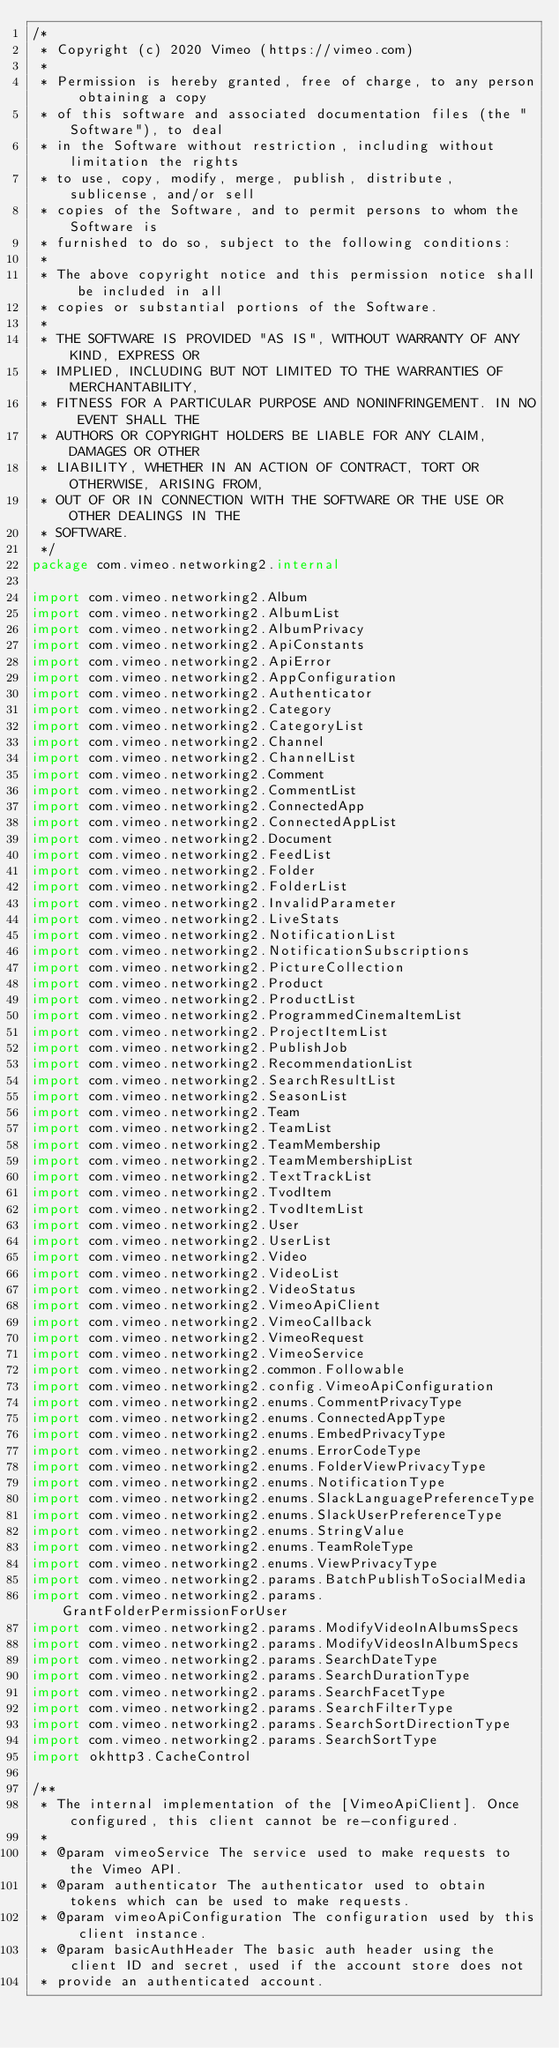<code> <loc_0><loc_0><loc_500><loc_500><_Kotlin_>/*
 * Copyright (c) 2020 Vimeo (https://vimeo.com)
 *
 * Permission is hereby granted, free of charge, to any person obtaining a copy
 * of this software and associated documentation files (the "Software"), to deal
 * in the Software without restriction, including without limitation the rights
 * to use, copy, modify, merge, publish, distribute, sublicense, and/or sell
 * copies of the Software, and to permit persons to whom the Software is
 * furnished to do so, subject to the following conditions:
 *
 * The above copyright notice and this permission notice shall be included in all
 * copies or substantial portions of the Software.
 *
 * THE SOFTWARE IS PROVIDED "AS IS", WITHOUT WARRANTY OF ANY KIND, EXPRESS OR
 * IMPLIED, INCLUDING BUT NOT LIMITED TO THE WARRANTIES OF MERCHANTABILITY,
 * FITNESS FOR A PARTICULAR PURPOSE AND NONINFRINGEMENT. IN NO EVENT SHALL THE
 * AUTHORS OR COPYRIGHT HOLDERS BE LIABLE FOR ANY CLAIM, DAMAGES OR OTHER
 * LIABILITY, WHETHER IN AN ACTION OF CONTRACT, TORT OR OTHERWISE, ARISING FROM,
 * OUT OF OR IN CONNECTION WITH THE SOFTWARE OR THE USE OR OTHER DEALINGS IN THE
 * SOFTWARE.
 */
package com.vimeo.networking2.internal

import com.vimeo.networking2.Album
import com.vimeo.networking2.AlbumList
import com.vimeo.networking2.AlbumPrivacy
import com.vimeo.networking2.ApiConstants
import com.vimeo.networking2.ApiError
import com.vimeo.networking2.AppConfiguration
import com.vimeo.networking2.Authenticator
import com.vimeo.networking2.Category
import com.vimeo.networking2.CategoryList
import com.vimeo.networking2.Channel
import com.vimeo.networking2.ChannelList
import com.vimeo.networking2.Comment
import com.vimeo.networking2.CommentList
import com.vimeo.networking2.ConnectedApp
import com.vimeo.networking2.ConnectedAppList
import com.vimeo.networking2.Document
import com.vimeo.networking2.FeedList
import com.vimeo.networking2.Folder
import com.vimeo.networking2.FolderList
import com.vimeo.networking2.InvalidParameter
import com.vimeo.networking2.LiveStats
import com.vimeo.networking2.NotificationList
import com.vimeo.networking2.NotificationSubscriptions
import com.vimeo.networking2.PictureCollection
import com.vimeo.networking2.Product
import com.vimeo.networking2.ProductList
import com.vimeo.networking2.ProgrammedCinemaItemList
import com.vimeo.networking2.ProjectItemList
import com.vimeo.networking2.PublishJob
import com.vimeo.networking2.RecommendationList
import com.vimeo.networking2.SearchResultList
import com.vimeo.networking2.SeasonList
import com.vimeo.networking2.Team
import com.vimeo.networking2.TeamList
import com.vimeo.networking2.TeamMembership
import com.vimeo.networking2.TeamMembershipList
import com.vimeo.networking2.TextTrackList
import com.vimeo.networking2.TvodItem
import com.vimeo.networking2.TvodItemList
import com.vimeo.networking2.User
import com.vimeo.networking2.UserList
import com.vimeo.networking2.Video
import com.vimeo.networking2.VideoList
import com.vimeo.networking2.VideoStatus
import com.vimeo.networking2.VimeoApiClient
import com.vimeo.networking2.VimeoCallback
import com.vimeo.networking2.VimeoRequest
import com.vimeo.networking2.VimeoService
import com.vimeo.networking2.common.Followable
import com.vimeo.networking2.config.VimeoApiConfiguration
import com.vimeo.networking2.enums.CommentPrivacyType
import com.vimeo.networking2.enums.ConnectedAppType
import com.vimeo.networking2.enums.EmbedPrivacyType
import com.vimeo.networking2.enums.ErrorCodeType
import com.vimeo.networking2.enums.FolderViewPrivacyType
import com.vimeo.networking2.enums.NotificationType
import com.vimeo.networking2.enums.SlackLanguagePreferenceType
import com.vimeo.networking2.enums.SlackUserPreferenceType
import com.vimeo.networking2.enums.StringValue
import com.vimeo.networking2.enums.TeamRoleType
import com.vimeo.networking2.enums.ViewPrivacyType
import com.vimeo.networking2.params.BatchPublishToSocialMedia
import com.vimeo.networking2.params.GrantFolderPermissionForUser
import com.vimeo.networking2.params.ModifyVideoInAlbumsSpecs
import com.vimeo.networking2.params.ModifyVideosInAlbumSpecs
import com.vimeo.networking2.params.SearchDateType
import com.vimeo.networking2.params.SearchDurationType
import com.vimeo.networking2.params.SearchFacetType
import com.vimeo.networking2.params.SearchFilterType
import com.vimeo.networking2.params.SearchSortDirectionType
import com.vimeo.networking2.params.SearchSortType
import okhttp3.CacheControl

/**
 * The internal implementation of the [VimeoApiClient]. Once configured, this client cannot be re-configured.
 *
 * @param vimeoService The service used to make requests to the Vimeo API.
 * @param authenticator The authenticator used to obtain tokens which can be used to make requests.
 * @param vimeoApiConfiguration The configuration used by this client instance.
 * @param basicAuthHeader The basic auth header using the client ID and secret, used if the account store does not
 * provide an authenticated account.</code> 